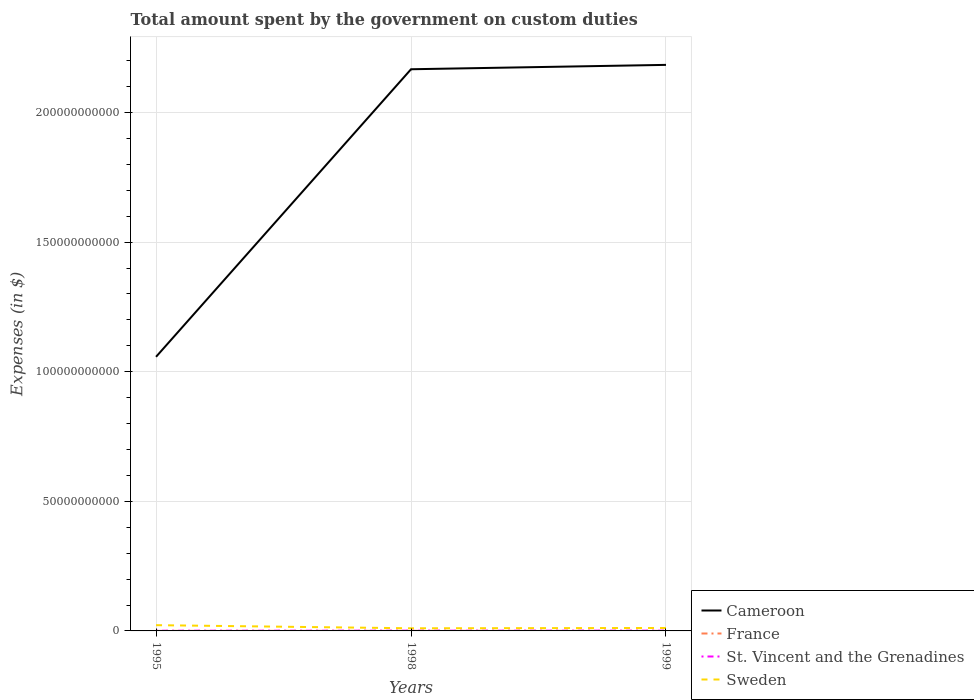How many different coloured lines are there?
Provide a short and direct response. 4. Across all years, what is the maximum amount spent on custom duties by the government in France?
Offer a very short reply. 2.00e+07. In which year was the amount spent on custom duties by the government in France maximum?
Your response must be concise. 1995. What is the total amount spent on custom duties by the government in St. Vincent and the Grenadines in the graph?
Make the answer very short. -6.90e+06. What is the difference between the highest and the second highest amount spent on custom duties by the government in Sweden?
Offer a very short reply. 1.20e+09. What is the difference between the highest and the lowest amount spent on custom duties by the government in France?
Your answer should be compact. 1. How many lines are there?
Offer a terse response. 4. How many years are there in the graph?
Ensure brevity in your answer.  3. What is the difference between two consecutive major ticks on the Y-axis?
Keep it short and to the point. 5.00e+1. Are the values on the major ticks of Y-axis written in scientific E-notation?
Provide a short and direct response. No. Does the graph contain any zero values?
Keep it short and to the point. No. Does the graph contain grids?
Provide a succinct answer. Yes. How are the legend labels stacked?
Keep it short and to the point. Vertical. What is the title of the graph?
Offer a very short reply. Total amount spent by the government on custom duties. Does "American Samoa" appear as one of the legend labels in the graph?
Provide a succinct answer. No. What is the label or title of the X-axis?
Your answer should be very brief. Years. What is the label or title of the Y-axis?
Make the answer very short. Expenses (in $). What is the Expenses (in $) of Cameroon in 1995?
Provide a short and direct response. 1.06e+11. What is the Expenses (in $) of France in 1995?
Your answer should be compact. 2.00e+07. What is the Expenses (in $) in St. Vincent and the Grenadines in 1995?
Offer a terse response. 8.46e+07. What is the Expenses (in $) of Sweden in 1995?
Make the answer very short. 2.22e+09. What is the Expenses (in $) of Cameroon in 1998?
Offer a very short reply. 2.17e+11. What is the Expenses (in $) of France in 1998?
Provide a short and direct response. 3.70e+07. What is the Expenses (in $) in St. Vincent and the Grenadines in 1998?
Keep it short and to the point. 1.01e+08. What is the Expenses (in $) in Sweden in 1998?
Your answer should be compact. 1.02e+09. What is the Expenses (in $) in Cameroon in 1999?
Ensure brevity in your answer.  2.18e+11. What is the Expenses (in $) in France in 1999?
Your answer should be compact. 2.40e+07. What is the Expenses (in $) in St. Vincent and the Grenadines in 1999?
Give a very brief answer. 1.08e+08. What is the Expenses (in $) in Sweden in 1999?
Your response must be concise. 1.14e+09. Across all years, what is the maximum Expenses (in $) of Cameroon?
Provide a short and direct response. 2.18e+11. Across all years, what is the maximum Expenses (in $) of France?
Ensure brevity in your answer.  3.70e+07. Across all years, what is the maximum Expenses (in $) of St. Vincent and the Grenadines?
Provide a short and direct response. 1.08e+08. Across all years, what is the maximum Expenses (in $) of Sweden?
Keep it short and to the point. 2.22e+09. Across all years, what is the minimum Expenses (in $) in Cameroon?
Provide a succinct answer. 1.06e+11. Across all years, what is the minimum Expenses (in $) in France?
Give a very brief answer. 2.00e+07. Across all years, what is the minimum Expenses (in $) in St. Vincent and the Grenadines?
Your answer should be compact. 8.46e+07. Across all years, what is the minimum Expenses (in $) in Sweden?
Keep it short and to the point. 1.02e+09. What is the total Expenses (in $) of Cameroon in the graph?
Keep it short and to the point. 5.41e+11. What is the total Expenses (in $) of France in the graph?
Ensure brevity in your answer.  8.10e+07. What is the total Expenses (in $) of St. Vincent and the Grenadines in the graph?
Offer a very short reply. 2.93e+08. What is the total Expenses (in $) in Sweden in the graph?
Make the answer very short. 4.38e+09. What is the difference between the Expenses (in $) in Cameroon in 1995 and that in 1998?
Offer a very short reply. -1.11e+11. What is the difference between the Expenses (in $) in France in 1995 and that in 1998?
Your answer should be very brief. -1.70e+07. What is the difference between the Expenses (in $) of St. Vincent and the Grenadines in 1995 and that in 1998?
Your response must be concise. -1.62e+07. What is the difference between the Expenses (in $) in Sweden in 1995 and that in 1998?
Give a very brief answer. 1.20e+09. What is the difference between the Expenses (in $) in Cameroon in 1995 and that in 1999?
Provide a succinct answer. -1.13e+11. What is the difference between the Expenses (in $) of France in 1995 and that in 1999?
Give a very brief answer. -4.00e+06. What is the difference between the Expenses (in $) in St. Vincent and the Grenadines in 1995 and that in 1999?
Make the answer very short. -2.31e+07. What is the difference between the Expenses (in $) of Sweden in 1995 and that in 1999?
Provide a short and direct response. 1.08e+09. What is the difference between the Expenses (in $) of Cameroon in 1998 and that in 1999?
Offer a terse response. -1.69e+09. What is the difference between the Expenses (in $) in France in 1998 and that in 1999?
Provide a succinct answer. 1.30e+07. What is the difference between the Expenses (in $) in St. Vincent and the Grenadines in 1998 and that in 1999?
Provide a succinct answer. -6.90e+06. What is the difference between the Expenses (in $) in Sweden in 1998 and that in 1999?
Offer a very short reply. -1.19e+08. What is the difference between the Expenses (in $) in Cameroon in 1995 and the Expenses (in $) in France in 1998?
Give a very brief answer. 1.06e+11. What is the difference between the Expenses (in $) in Cameroon in 1995 and the Expenses (in $) in St. Vincent and the Grenadines in 1998?
Your answer should be compact. 1.06e+11. What is the difference between the Expenses (in $) in Cameroon in 1995 and the Expenses (in $) in Sweden in 1998?
Make the answer very short. 1.05e+11. What is the difference between the Expenses (in $) of France in 1995 and the Expenses (in $) of St. Vincent and the Grenadines in 1998?
Your answer should be compact. -8.08e+07. What is the difference between the Expenses (in $) in France in 1995 and the Expenses (in $) in Sweden in 1998?
Give a very brief answer. -9.99e+08. What is the difference between the Expenses (in $) in St. Vincent and the Grenadines in 1995 and the Expenses (in $) in Sweden in 1998?
Provide a short and direct response. -9.34e+08. What is the difference between the Expenses (in $) of Cameroon in 1995 and the Expenses (in $) of France in 1999?
Your response must be concise. 1.06e+11. What is the difference between the Expenses (in $) of Cameroon in 1995 and the Expenses (in $) of St. Vincent and the Grenadines in 1999?
Provide a succinct answer. 1.06e+11. What is the difference between the Expenses (in $) of Cameroon in 1995 and the Expenses (in $) of Sweden in 1999?
Offer a very short reply. 1.05e+11. What is the difference between the Expenses (in $) of France in 1995 and the Expenses (in $) of St. Vincent and the Grenadines in 1999?
Your answer should be compact. -8.77e+07. What is the difference between the Expenses (in $) of France in 1995 and the Expenses (in $) of Sweden in 1999?
Ensure brevity in your answer.  -1.12e+09. What is the difference between the Expenses (in $) in St. Vincent and the Grenadines in 1995 and the Expenses (in $) in Sweden in 1999?
Make the answer very short. -1.05e+09. What is the difference between the Expenses (in $) in Cameroon in 1998 and the Expenses (in $) in France in 1999?
Your answer should be compact. 2.17e+11. What is the difference between the Expenses (in $) in Cameroon in 1998 and the Expenses (in $) in St. Vincent and the Grenadines in 1999?
Provide a succinct answer. 2.17e+11. What is the difference between the Expenses (in $) in Cameroon in 1998 and the Expenses (in $) in Sweden in 1999?
Offer a terse response. 2.16e+11. What is the difference between the Expenses (in $) of France in 1998 and the Expenses (in $) of St. Vincent and the Grenadines in 1999?
Your answer should be compact. -7.07e+07. What is the difference between the Expenses (in $) in France in 1998 and the Expenses (in $) in Sweden in 1999?
Offer a terse response. -1.10e+09. What is the difference between the Expenses (in $) of St. Vincent and the Grenadines in 1998 and the Expenses (in $) of Sweden in 1999?
Your response must be concise. -1.04e+09. What is the average Expenses (in $) of Cameroon per year?
Provide a succinct answer. 1.80e+11. What is the average Expenses (in $) in France per year?
Offer a very short reply. 2.70e+07. What is the average Expenses (in $) of St. Vincent and the Grenadines per year?
Offer a terse response. 9.77e+07. What is the average Expenses (in $) in Sweden per year?
Offer a very short reply. 1.46e+09. In the year 1995, what is the difference between the Expenses (in $) in Cameroon and Expenses (in $) in France?
Offer a very short reply. 1.06e+11. In the year 1995, what is the difference between the Expenses (in $) of Cameroon and Expenses (in $) of St. Vincent and the Grenadines?
Offer a very short reply. 1.06e+11. In the year 1995, what is the difference between the Expenses (in $) in Cameroon and Expenses (in $) in Sweden?
Provide a short and direct response. 1.04e+11. In the year 1995, what is the difference between the Expenses (in $) of France and Expenses (in $) of St. Vincent and the Grenadines?
Provide a succinct answer. -6.46e+07. In the year 1995, what is the difference between the Expenses (in $) in France and Expenses (in $) in Sweden?
Give a very brief answer. -2.20e+09. In the year 1995, what is the difference between the Expenses (in $) in St. Vincent and the Grenadines and Expenses (in $) in Sweden?
Offer a very short reply. -2.14e+09. In the year 1998, what is the difference between the Expenses (in $) in Cameroon and Expenses (in $) in France?
Provide a succinct answer. 2.17e+11. In the year 1998, what is the difference between the Expenses (in $) of Cameroon and Expenses (in $) of St. Vincent and the Grenadines?
Offer a terse response. 2.17e+11. In the year 1998, what is the difference between the Expenses (in $) of Cameroon and Expenses (in $) of Sweden?
Offer a very short reply. 2.16e+11. In the year 1998, what is the difference between the Expenses (in $) in France and Expenses (in $) in St. Vincent and the Grenadines?
Offer a terse response. -6.38e+07. In the year 1998, what is the difference between the Expenses (in $) of France and Expenses (in $) of Sweden?
Your answer should be very brief. -9.82e+08. In the year 1998, what is the difference between the Expenses (in $) of St. Vincent and the Grenadines and Expenses (in $) of Sweden?
Your response must be concise. -9.18e+08. In the year 1999, what is the difference between the Expenses (in $) of Cameroon and Expenses (in $) of France?
Offer a very short reply. 2.18e+11. In the year 1999, what is the difference between the Expenses (in $) of Cameroon and Expenses (in $) of St. Vincent and the Grenadines?
Your answer should be compact. 2.18e+11. In the year 1999, what is the difference between the Expenses (in $) in Cameroon and Expenses (in $) in Sweden?
Your answer should be compact. 2.17e+11. In the year 1999, what is the difference between the Expenses (in $) in France and Expenses (in $) in St. Vincent and the Grenadines?
Offer a terse response. -8.37e+07. In the year 1999, what is the difference between the Expenses (in $) in France and Expenses (in $) in Sweden?
Your answer should be very brief. -1.11e+09. In the year 1999, what is the difference between the Expenses (in $) of St. Vincent and the Grenadines and Expenses (in $) of Sweden?
Keep it short and to the point. -1.03e+09. What is the ratio of the Expenses (in $) of Cameroon in 1995 to that in 1998?
Ensure brevity in your answer.  0.49. What is the ratio of the Expenses (in $) of France in 1995 to that in 1998?
Give a very brief answer. 0.54. What is the ratio of the Expenses (in $) in St. Vincent and the Grenadines in 1995 to that in 1998?
Keep it short and to the point. 0.84. What is the ratio of the Expenses (in $) of Sweden in 1995 to that in 1998?
Ensure brevity in your answer.  2.18. What is the ratio of the Expenses (in $) of Cameroon in 1995 to that in 1999?
Your answer should be compact. 0.48. What is the ratio of the Expenses (in $) in St. Vincent and the Grenadines in 1995 to that in 1999?
Keep it short and to the point. 0.79. What is the ratio of the Expenses (in $) of Sweden in 1995 to that in 1999?
Give a very brief answer. 1.95. What is the ratio of the Expenses (in $) in Cameroon in 1998 to that in 1999?
Provide a succinct answer. 0.99. What is the ratio of the Expenses (in $) of France in 1998 to that in 1999?
Make the answer very short. 1.54. What is the ratio of the Expenses (in $) of St. Vincent and the Grenadines in 1998 to that in 1999?
Offer a terse response. 0.94. What is the ratio of the Expenses (in $) of Sweden in 1998 to that in 1999?
Provide a succinct answer. 0.9. What is the difference between the highest and the second highest Expenses (in $) in Cameroon?
Your answer should be very brief. 1.69e+09. What is the difference between the highest and the second highest Expenses (in $) of France?
Keep it short and to the point. 1.30e+07. What is the difference between the highest and the second highest Expenses (in $) in St. Vincent and the Grenadines?
Keep it short and to the point. 6.90e+06. What is the difference between the highest and the second highest Expenses (in $) of Sweden?
Ensure brevity in your answer.  1.08e+09. What is the difference between the highest and the lowest Expenses (in $) in Cameroon?
Your answer should be very brief. 1.13e+11. What is the difference between the highest and the lowest Expenses (in $) of France?
Provide a short and direct response. 1.70e+07. What is the difference between the highest and the lowest Expenses (in $) of St. Vincent and the Grenadines?
Your response must be concise. 2.31e+07. What is the difference between the highest and the lowest Expenses (in $) of Sweden?
Offer a very short reply. 1.20e+09. 